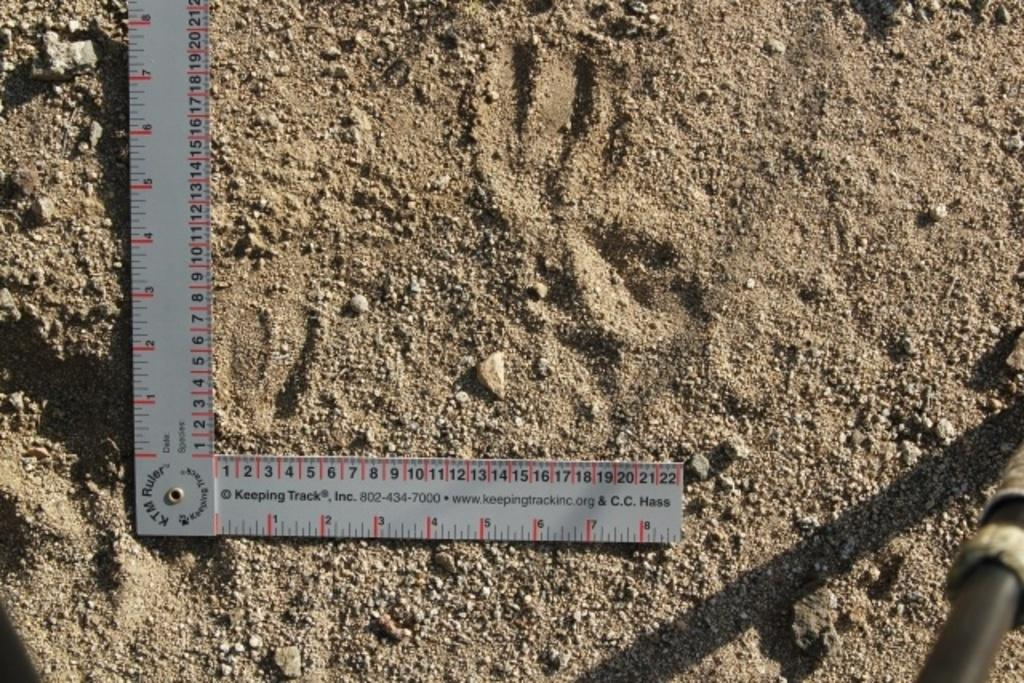<image>
Create a compact narrative representing the image presented. A KTM Ruler is being used to measure paw prints in the dirt. 